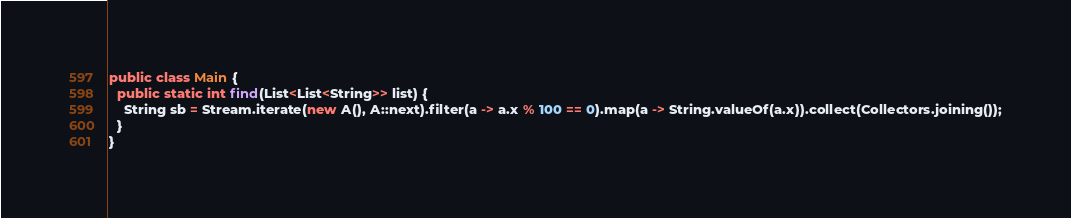Convert code to text. <code><loc_0><loc_0><loc_500><loc_500><_Java_>

public class Main {
  public static int find(List<List<String>> list) {
    String sb = Stream.iterate(new A(), A::next).filter(a -> a.x % 100 == 0).map(a -> String.valueOf(a.x)).collect(Collectors.joining());
  }
}</code> 